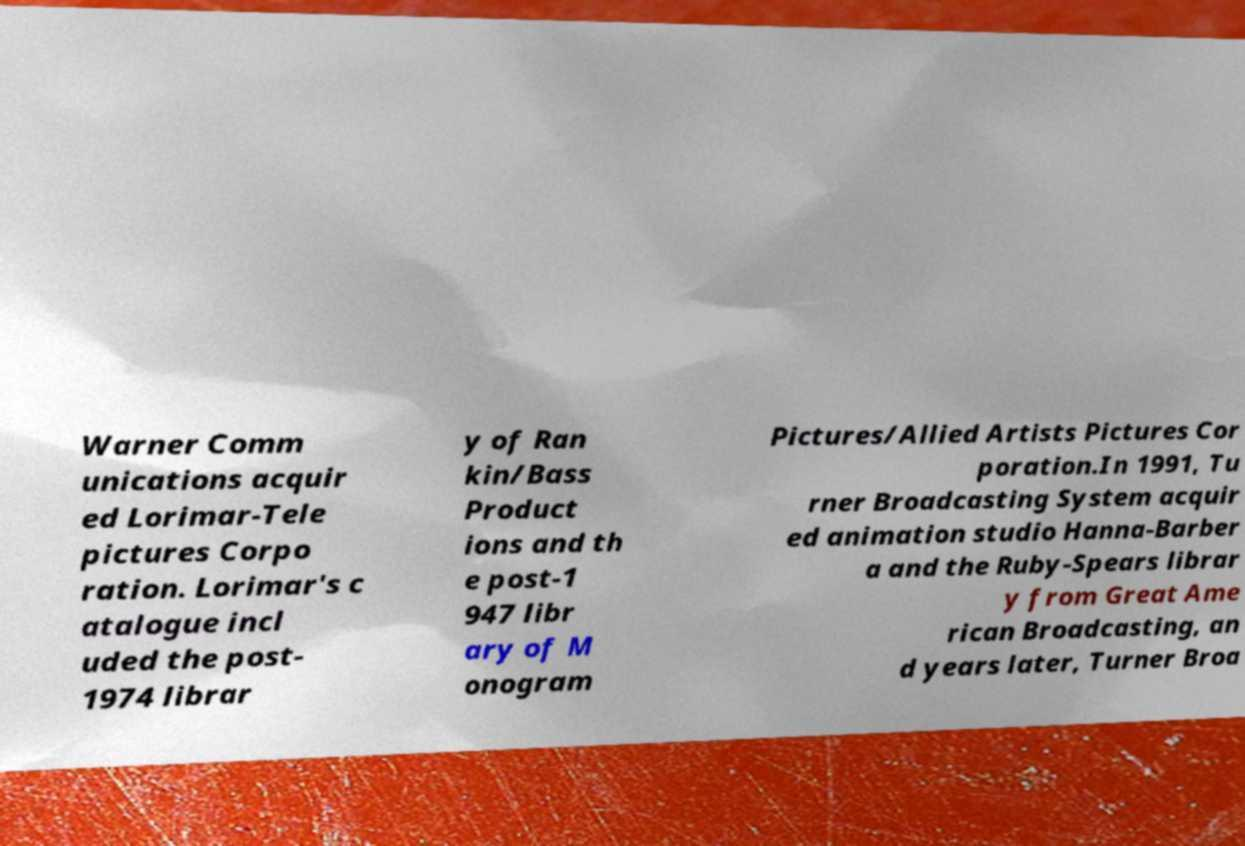I need the written content from this picture converted into text. Can you do that? Warner Comm unications acquir ed Lorimar-Tele pictures Corpo ration. Lorimar's c atalogue incl uded the post- 1974 librar y of Ran kin/Bass Product ions and th e post-1 947 libr ary of M onogram Pictures/Allied Artists Pictures Cor poration.In 1991, Tu rner Broadcasting System acquir ed animation studio Hanna-Barber a and the Ruby-Spears librar y from Great Ame rican Broadcasting, an d years later, Turner Broa 